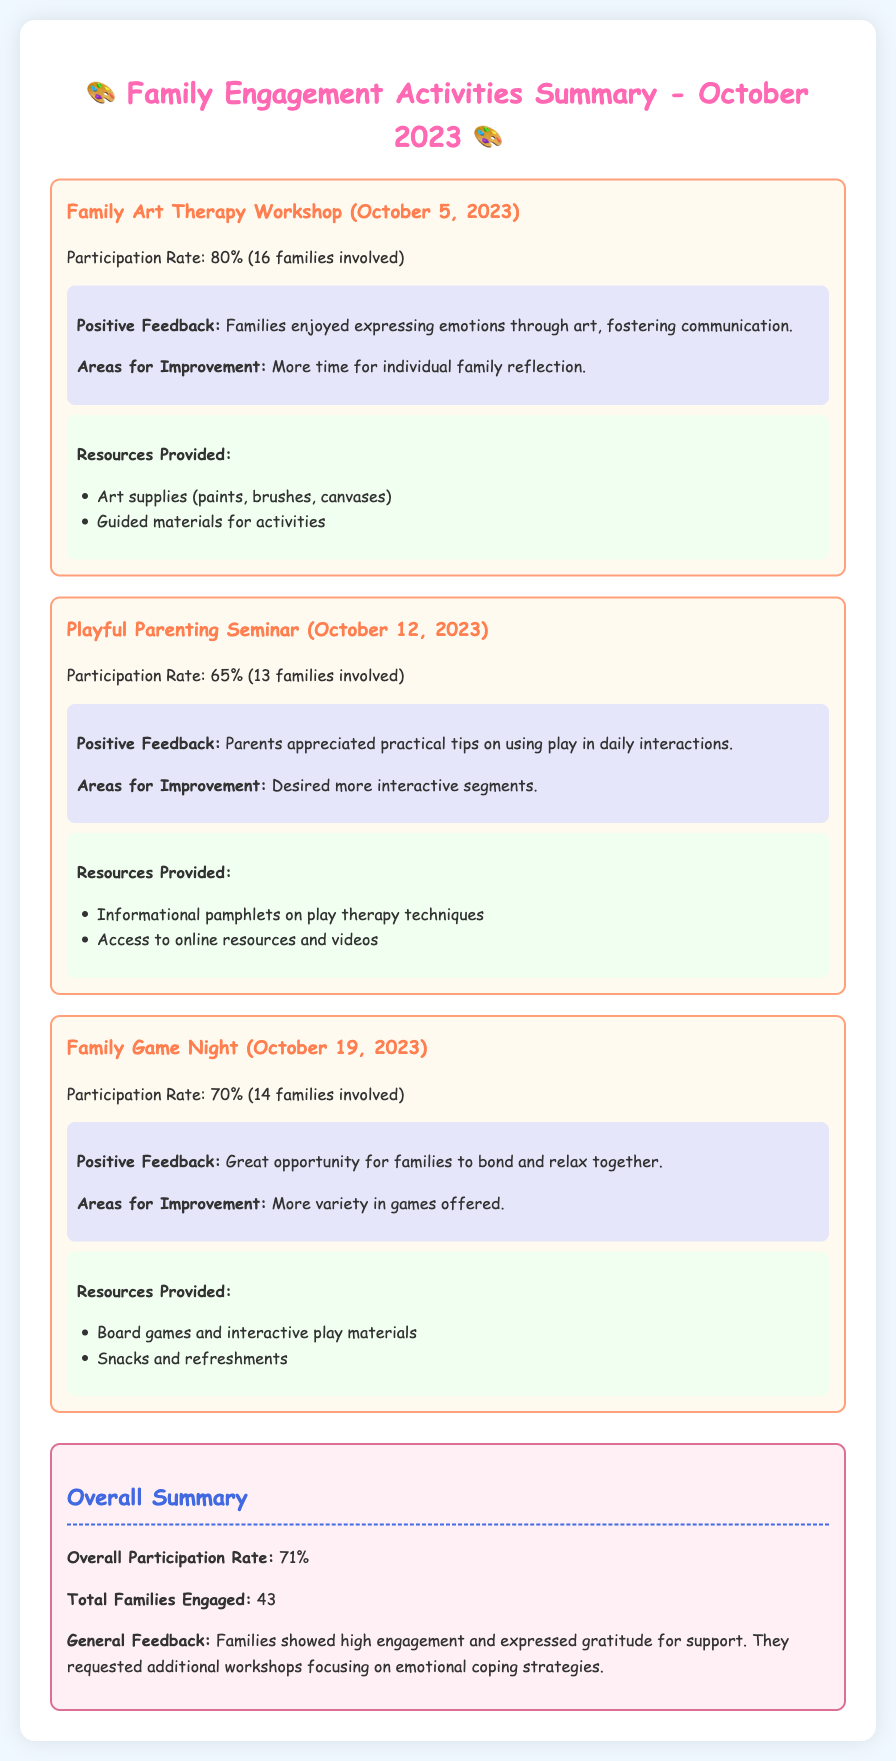What is the participation rate for the Family Art Therapy Workshop? The participation rate for this workshop is directly stated in the document as 80%.
Answer: 80% How many families participated in the Playful Parenting Seminar? The document specifies that 13 families were involved in this seminar.
Answer: 13 What suggestions did families have for improving the Family Game Night? Families expressed a desire for more variety in the games offered, which is noted under areas for improvement.
Answer: More variety in games What is the overall participation rate for all activities? The document provides an overall participation rate of 71%, summarizing the engagement across all activities.
Answer: 71% What resources were provided during the Family Game Night? The document lists the resources for this event, including board games and snacks.
Answer: Board games and snacks What general feedback did families provide? The general feedback indicates that families showed high engagement and expressed gratitude for support, as mentioned in the summary.
Answer: High engagement and gratitude for support What date did the Playful Parenting Seminar occur? The specific date for this seminar is provided in the document, which is October 12, 2023.
Answer: October 12, 2023 How many families participated in total across all activities? The summary indicates that a total of 43 families were engaged in all activities combined.
Answer: 43 